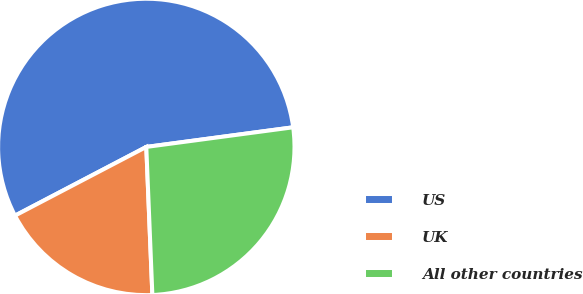Convert chart. <chart><loc_0><loc_0><loc_500><loc_500><pie_chart><fcel>US<fcel>UK<fcel>All other countries<nl><fcel>55.55%<fcel>17.98%<fcel>26.46%<nl></chart> 